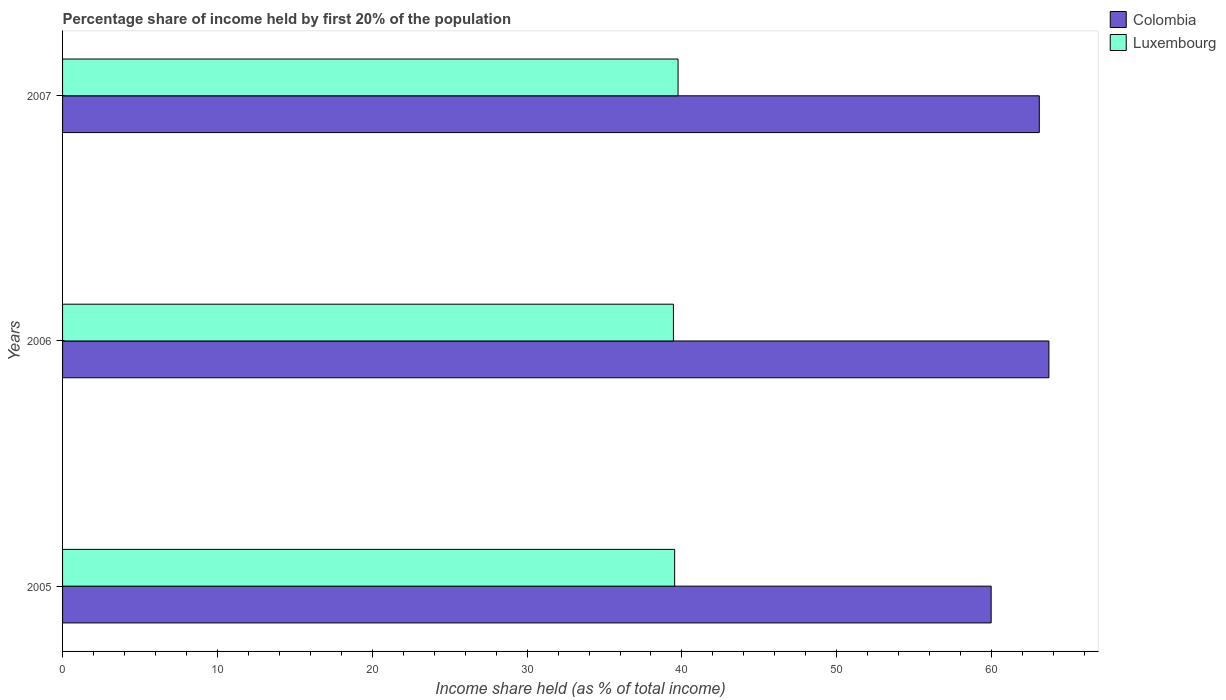How many different coloured bars are there?
Offer a very short reply. 2. Are the number of bars on each tick of the Y-axis equal?
Your answer should be very brief. Yes. What is the share of income held by first 20% of the population in Colombia in 2007?
Keep it short and to the point. 63.08. Across all years, what is the maximum share of income held by first 20% of the population in Colombia?
Your answer should be compact. 63.7. Across all years, what is the minimum share of income held by first 20% of the population in Colombia?
Ensure brevity in your answer.  59.97. In which year was the share of income held by first 20% of the population in Colombia maximum?
Provide a succinct answer. 2006. What is the total share of income held by first 20% of the population in Luxembourg in the graph?
Offer a terse response. 118.73. What is the difference between the share of income held by first 20% of the population in Colombia in 2005 and that in 2007?
Your answer should be compact. -3.11. What is the difference between the share of income held by first 20% of the population in Colombia in 2006 and the share of income held by first 20% of the population in Luxembourg in 2005?
Provide a short and direct response. 24.17. What is the average share of income held by first 20% of the population in Colombia per year?
Offer a terse response. 62.25. In the year 2006, what is the difference between the share of income held by first 20% of the population in Luxembourg and share of income held by first 20% of the population in Colombia?
Your response must be concise. -24.25. In how many years, is the share of income held by first 20% of the population in Colombia greater than 32 %?
Provide a short and direct response. 3. What is the ratio of the share of income held by first 20% of the population in Colombia in 2005 to that in 2006?
Provide a short and direct response. 0.94. Is the difference between the share of income held by first 20% of the population in Luxembourg in 2006 and 2007 greater than the difference between the share of income held by first 20% of the population in Colombia in 2006 and 2007?
Ensure brevity in your answer.  No. What is the difference between the highest and the second highest share of income held by first 20% of the population in Luxembourg?
Offer a very short reply. 0.22. What is the difference between the highest and the lowest share of income held by first 20% of the population in Colombia?
Ensure brevity in your answer.  3.73. What does the 1st bar from the top in 2006 represents?
Ensure brevity in your answer.  Luxembourg. What does the 2nd bar from the bottom in 2006 represents?
Offer a terse response. Luxembourg. How many bars are there?
Offer a terse response. 6. How many years are there in the graph?
Offer a terse response. 3. What is the difference between two consecutive major ticks on the X-axis?
Provide a succinct answer. 10. Does the graph contain grids?
Offer a terse response. No. Where does the legend appear in the graph?
Give a very brief answer. Top right. How many legend labels are there?
Ensure brevity in your answer.  2. What is the title of the graph?
Keep it short and to the point. Percentage share of income held by first 20% of the population. What is the label or title of the X-axis?
Ensure brevity in your answer.  Income share held (as % of total income). What is the label or title of the Y-axis?
Offer a very short reply. Years. What is the Income share held (as % of total income) of Colombia in 2005?
Make the answer very short. 59.97. What is the Income share held (as % of total income) in Luxembourg in 2005?
Keep it short and to the point. 39.53. What is the Income share held (as % of total income) in Colombia in 2006?
Your response must be concise. 63.7. What is the Income share held (as % of total income) of Luxembourg in 2006?
Your answer should be very brief. 39.45. What is the Income share held (as % of total income) of Colombia in 2007?
Offer a terse response. 63.08. What is the Income share held (as % of total income) of Luxembourg in 2007?
Your answer should be very brief. 39.75. Across all years, what is the maximum Income share held (as % of total income) in Colombia?
Make the answer very short. 63.7. Across all years, what is the maximum Income share held (as % of total income) in Luxembourg?
Offer a very short reply. 39.75. Across all years, what is the minimum Income share held (as % of total income) in Colombia?
Your answer should be compact. 59.97. Across all years, what is the minimum Income share held (as % of total income) of Luxembourg?
Keep it short and to the point. 39.45. What is the total Income share held (as % of total income) in Colombia in the graph?
Ensure brevity in your answer.  186.75. What is the total Income share held (as % of total income) in Luxembourg in the graph?
Offer a terse response. 118.73. What is the difference between the Income share held (as % of total income) in Colombia in 2005 and that in 2006?
Provide a succinct answer. -3.73. What is the difference between the Income share held (as % of total income) in Luxembourg in 2005 and that in 2006?
Give a very brief answer. 0.08. What is the difference between the Income share held (as % of total income) in Colombia in 2005 and that in 2007?
Provide a succinct answer. -3.11. What is the difference between the Income share held (as % of total income) of Luxembourg in 2005 and that in 2007?
Make the answer very short. -0.22. What is the difference between the Income share held (as % of total income) of Colombia in 2006 and that in 2007?
Offer a terse response. 0.62. What is the difference between the Income share held (as % of total income) of Luxembourg in 2006 and that in 2007?
Your answer should be compact. -0.3. What is the difference between the Income share held (as % of total income) in Colombia in 2005 and the Income share held (as % of total income) in Luxembourg in 2006?
Ensure brevity in your answer.  20.52. What is the difference between the Income share held (as % of total income) of Colombia in 2005 and the Income share held (as % of total income) of Luxembourg in 2007?
Your response must be concise. 20.22. What is the difference between the Income share held (as % of total income) in Colombia in 2006 and the Income share held (as % of total income) in Luxembourg in 2007?
Provide a short and direct response. 23.95. What is the average Income share held (as % of total income) in Colombia per year?
Your response must be concise. 62.25. What is the average Income share held (as % of total income) in Luxembourg per year?
Offer a terse response. 39.58. In the year 2005, what is the difference between the Income share held (as % of total income) in Colombia and Income share held (as % of total income) in Luxembourg?
Give a very brief answer. 20.44. In the year 2006, what is the difference between the Income share held (as % of total income) in Colombia and Income share held (as % of total income) in Luxembourg?
Give a very brief answer. 24.25. In the year 2007, what is the difference between the Income share held (as % of total income) of Colombia and Income share held (as % of total income) of Luxembourg?
Give a very brief answer. 23.33. What is the ratio of the Income share held (as % of total income) of Colombia in 2005 to that in 2006?
Your answer should be very brief. 0.94. What is the ratio of the Income share held (as % of total income) in Luxembourg in 2005 to that in 2006?
Your answer should be very brief. 1. What is the ratio of the Income share held (as % of total income) of Colombia in 2005 to that in 2007?
Provide a short and direct response. 0.95. What is the ratio of the Income share held (as % of total income) in Luxembourg in 2005 to that in 2007?
Offer a terse response. 0.99. What is the ratio of the Income share held (as % of total income) in Colombia in 2006 to that in 2007?
Your answer should be very brief. 1.01. What is the ratio of the Income share held (as % of total income) of Luxembourg in 2006 to that in 2007?
Your answer should be compact. 0.99. What is the difference between the highest and the second highest Income share held (as % of total income) in Colombia?
Provide a succinct answer. 0.62. What is the difference between the highest and the second highest Income share held (as % of total income) in Luxembourg?
Provide a succinct answer. 0.22. What is the difference between the highest and the lowest Income share held (as % of total income) of Colombia?
Offer a terse response. 3.73. 